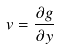Convert formula to latex. <formula><loc_0><loc_0><loc_500><loc_500>v = \frac { \partial g } { \partial y }</formula> 